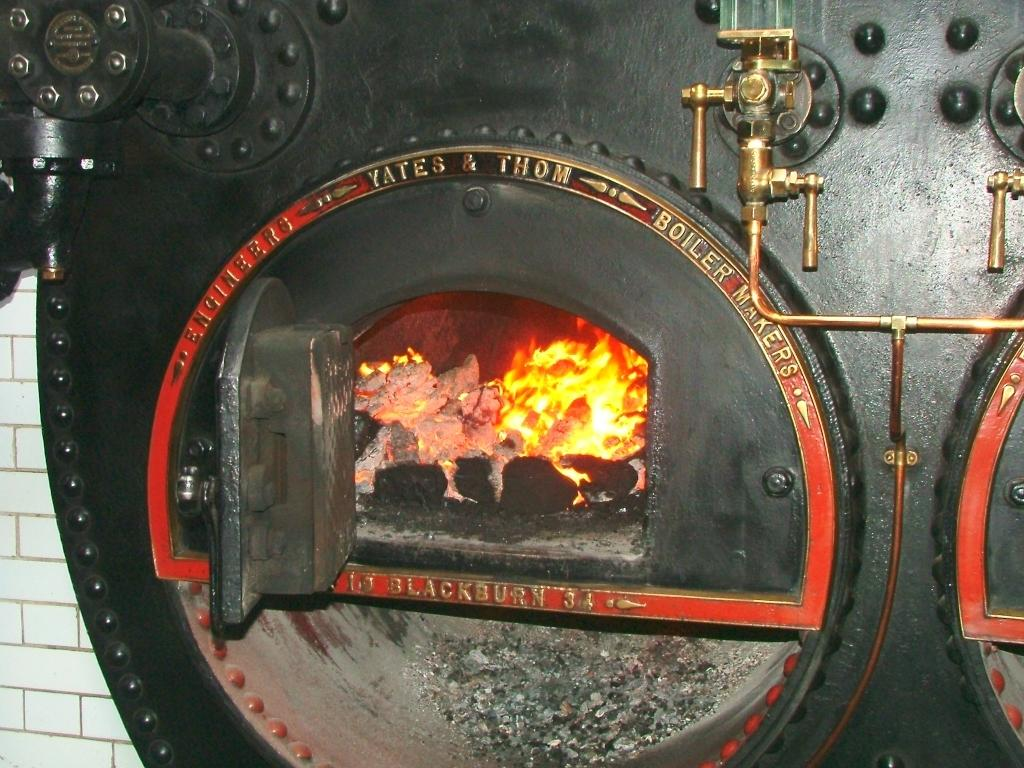What is the main object in the image? There is a machine in the image. What can be seen connected to the machine? There are pipes in the image. What is happening with the fire in the image? There is fire in the image. What can be seen in the background of the image? There is a wall visible in the background of the image. What type of shade is being used to protect the sticks from the fire in the image? There are no sticks or shade present in the image. 